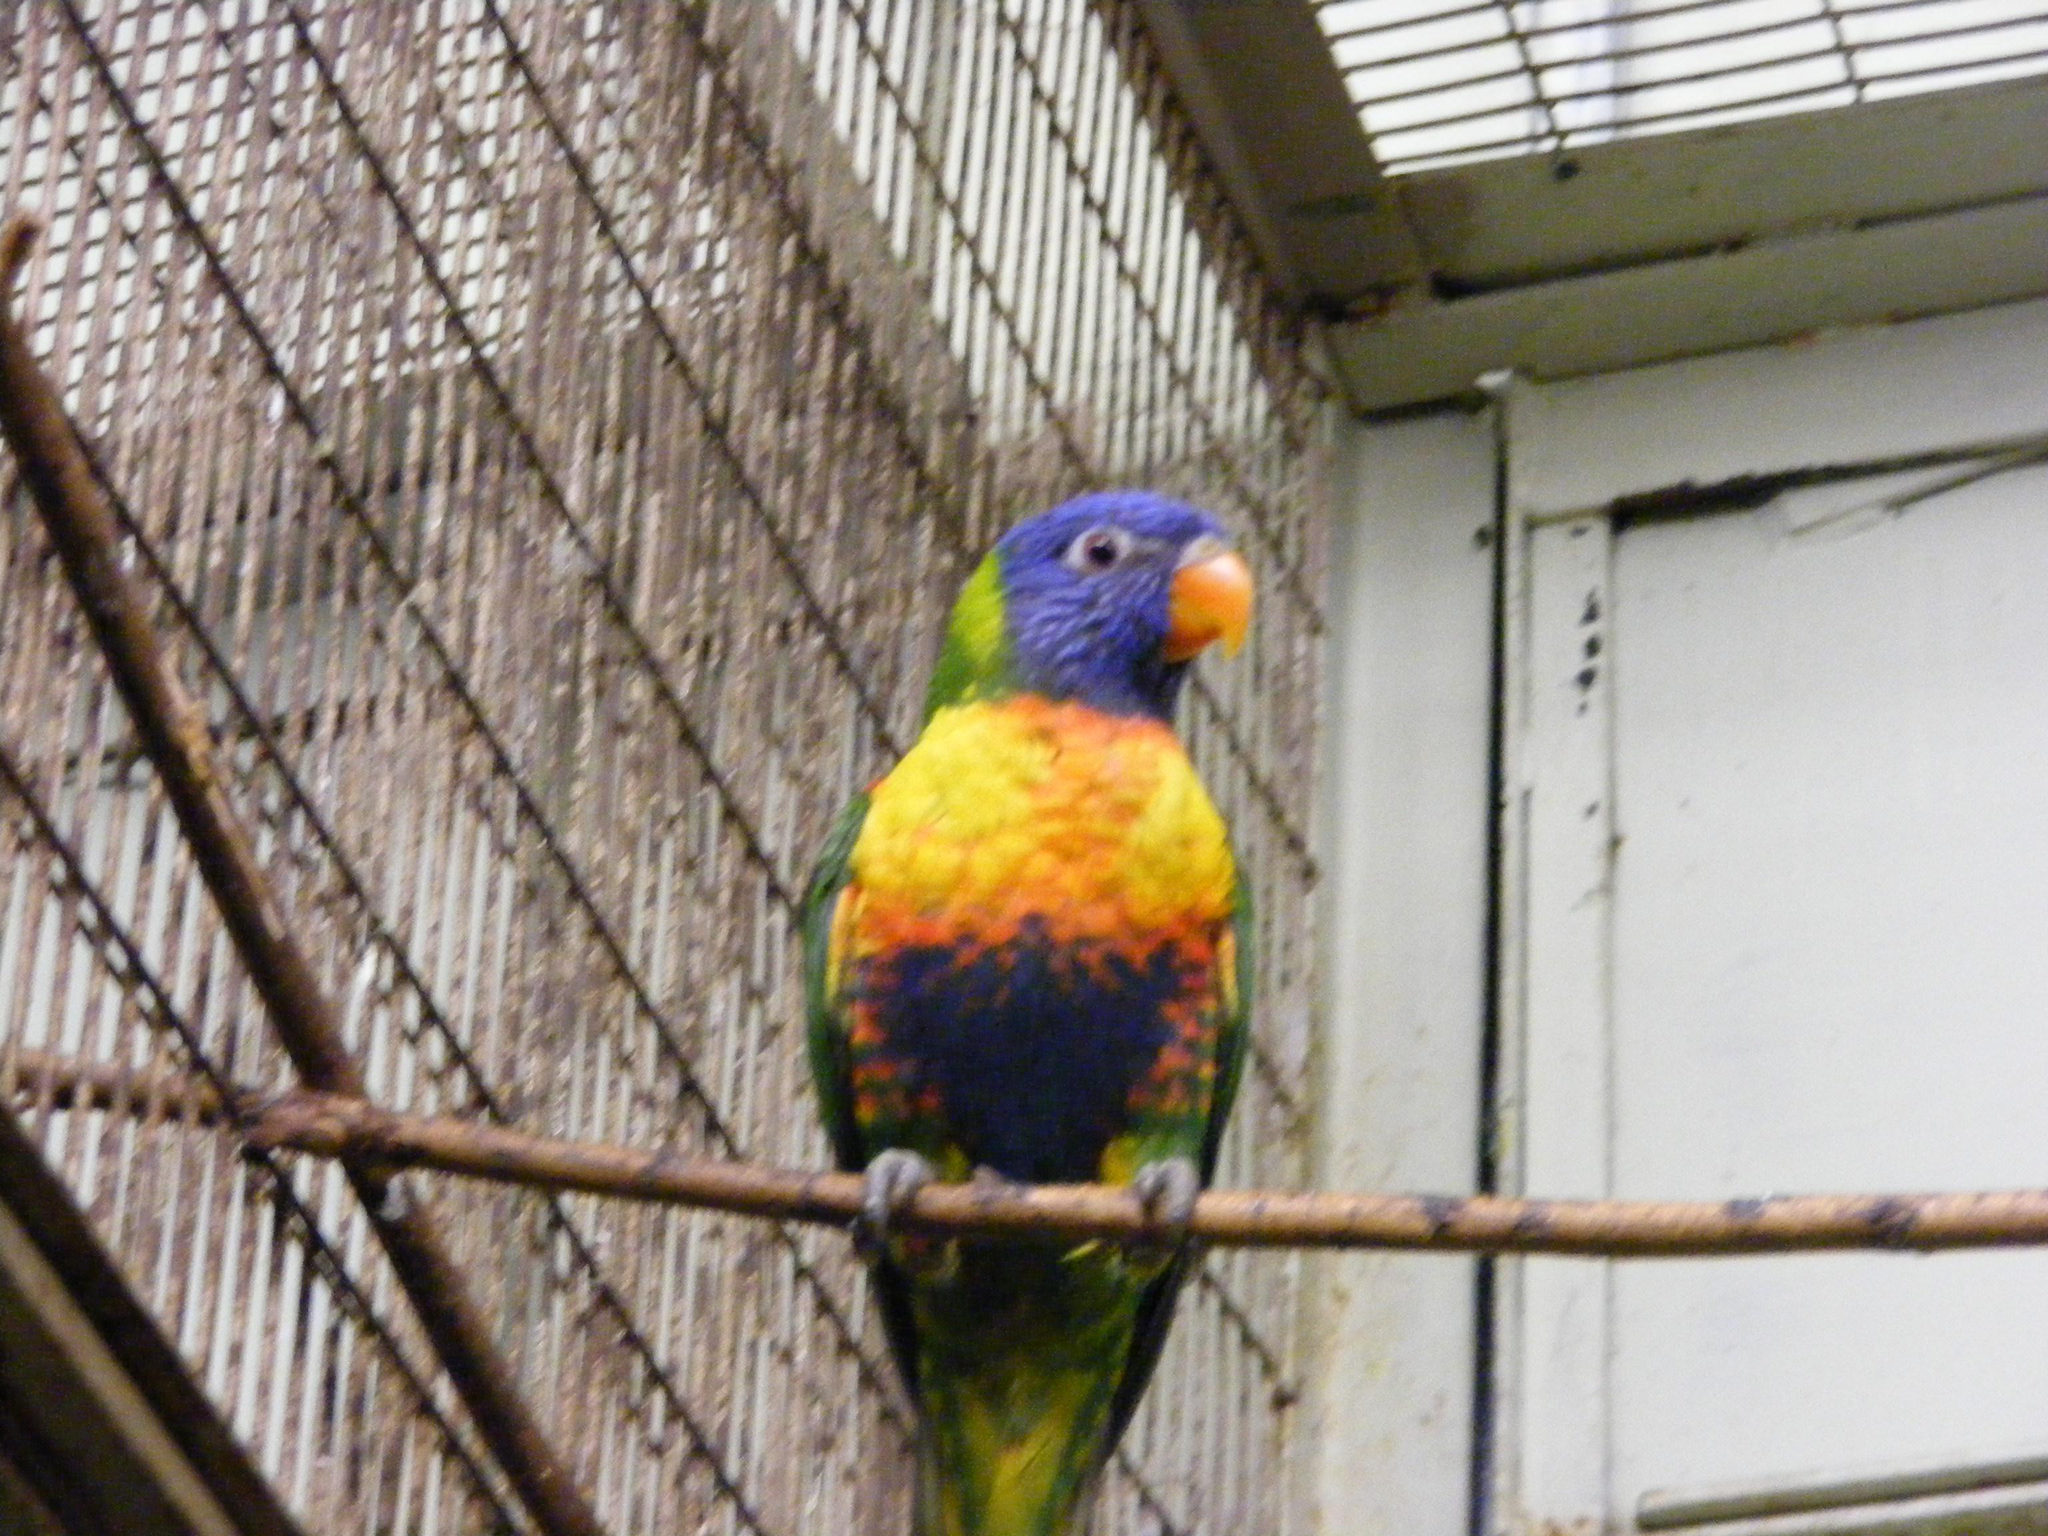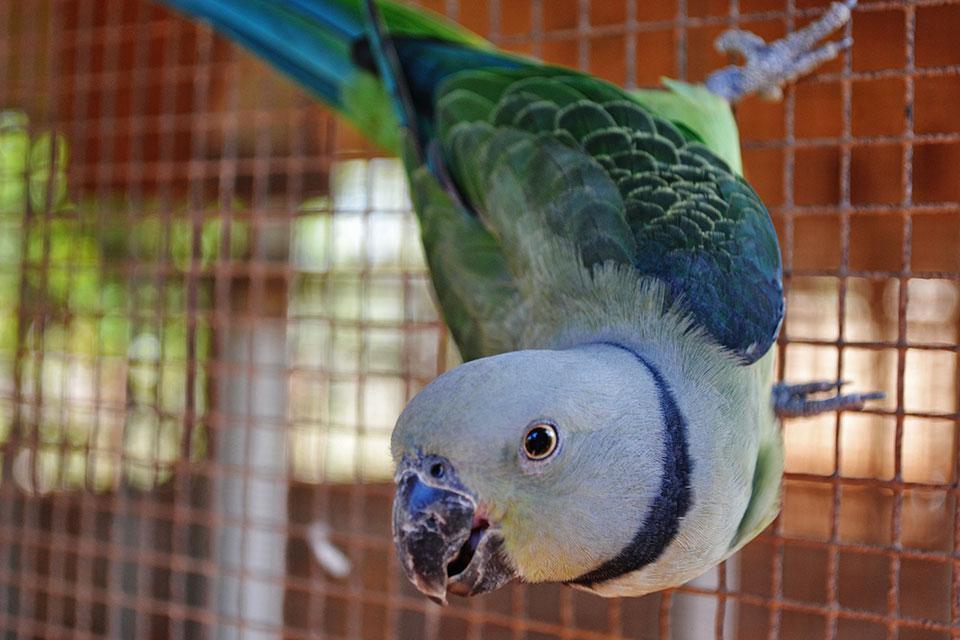The first image is the image on the left, the second image is the image on the right. Analyze the images presented: Is the assertion "Only one parrot can be seen in each of the images." valid? Answer yes or no. Yes. The first image is the image on the left, the second image is the image on the right. For the images displayed, is the sentence "There is a bird that is hanging with its feet above most of its body." factually correct? Answer yes or no. Yes. 